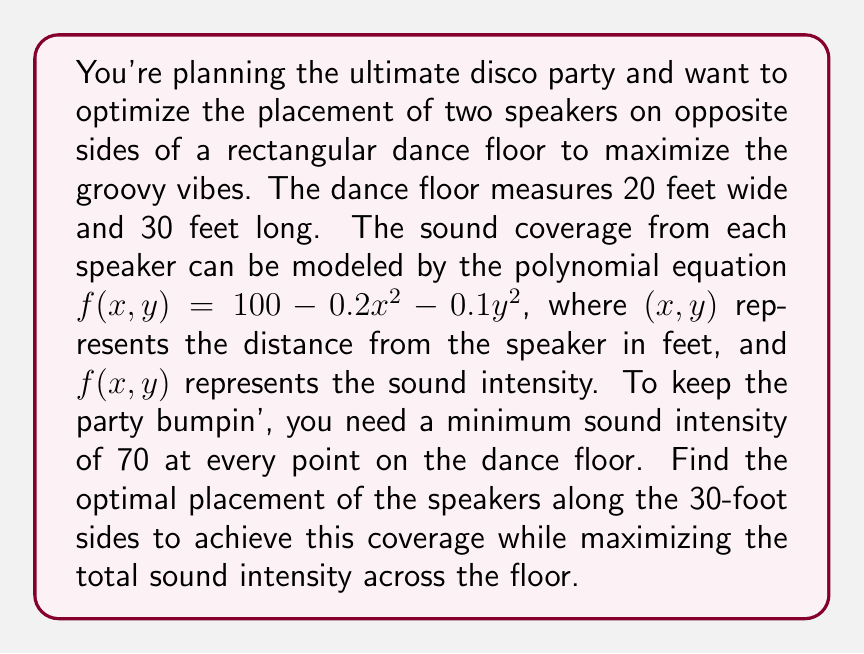Could you help me with this problem? Let's approach this funky problem step by step:

1) First, let's visualize the setup. We have two speakers on opposite 30-foot sides of the dance floor. Let's place the origin at one corner and denote the speaker positions as $(0,y_1)$ and $(20,y_2)$.

2) The sound intensity at any point $(x,y)$ on the dance floor is the sum of the contributions from both speakers:

   $I(x,y) = f(x-0,y-y_1) + f(x-20,y-y_2)$

3) Expanding this using the given formula:

   $I(x,y) = (100 - 0.2x^2 - 0.1(y-y_1)^2) + (100 - 0.2(x-20)^2 - 0.1(y-y_2)^2)$

4) To ensure a minimum intensity of 70 everywhere, we need:

   $\min_{0\leq x\leq 20, 0\leq y\leq 30} I(x,y) \geq 70$

5) The minimum will occur at the point farthest from both speakers, which is the center of the dance floor: $(10,15)$. So we need:

   $I(10,15) \geq 70$

6) Substituting into our equation:

   $(100 - 0.2(10)^2 - 0.1(15-y_1)^2) + (100 - 0.2(10)^2 - 0.1(15-y_2)^2) \geq 70$

7) Simplifying:

   $200 - 40 - 0.1(225 - 30y_1 + y_1^2) - 0.1(225 - 30y_2 + y_2^2) \geq 70$
   $160 - 22.5 + 3y_1 - 0.1y_1^2 - 22.5 + 3y_2 - 0.1y_2^2 \geq 70$
   $3y_1 - 0.1y_1^2 + 3y_2 - 0.1y_2^2 \geq 45$

8) To maximize total sound intensity, we want to maximize $y_1$ and $y_2$ while satisfying this constraint. Due to symmetry, the optimal solution will have $y_1 = y_2 = y$.

9) Substituting this into our inequality:

   $6y - 0.2y^2 \geq 45$
   $0.2y^2 - 6y + 45 \leq 0$

10) Solving this quadratic inequality:

    $y = \frac{6 \pm \sqrt{36 - 4(0.2)(45)}}{2(0.2)} = \frac{6 \pm \sqrt{36 - 36}}{0.4} = 15$

Therefore, the optimal placement is 15 feet from each end of the 30-foot sides.
Answer: The optimal placement for the speakers is 15 feet from each end of the 30-foot sides of the dance floor, at coordinates $(0,15)$ and $(20,15)$. 